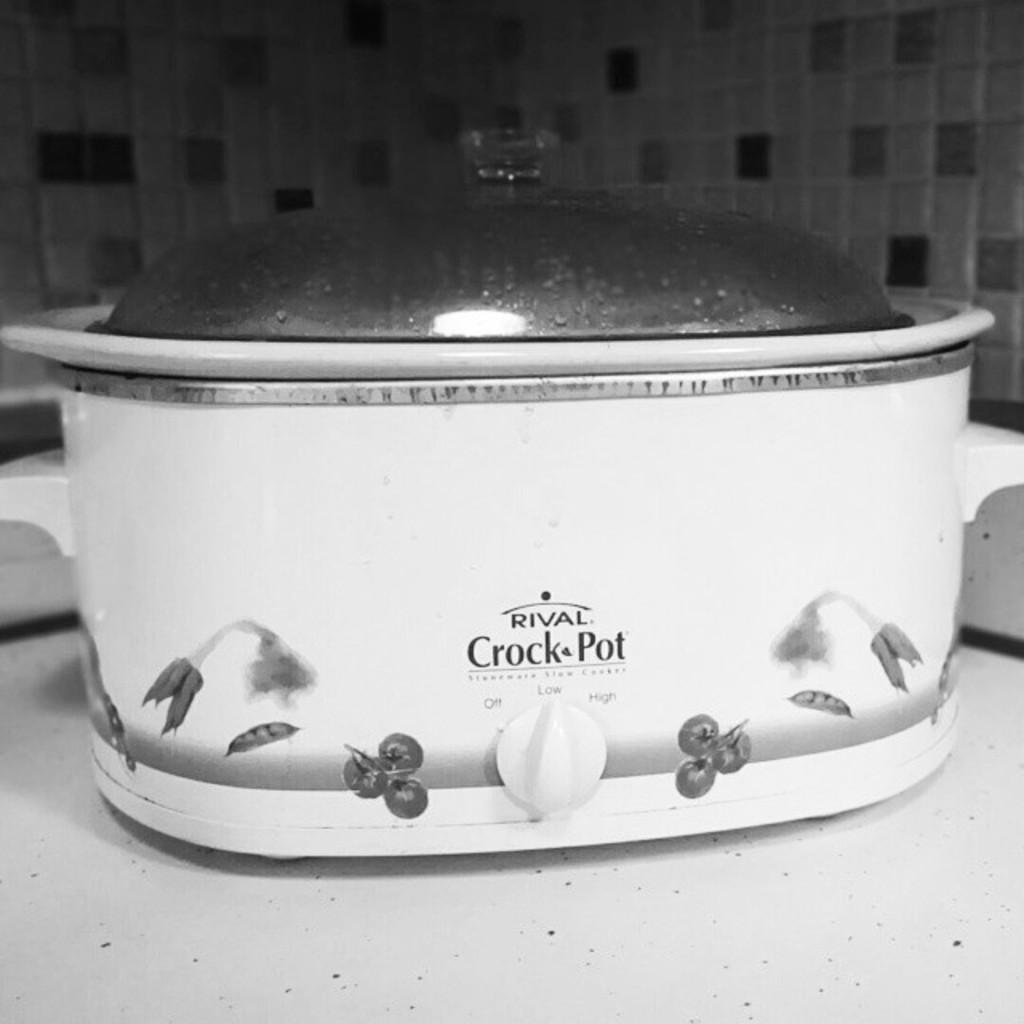<image>
Render a clear and concise summary of the photo. Large white crock pot that says RIVAL on it on top of a table. 